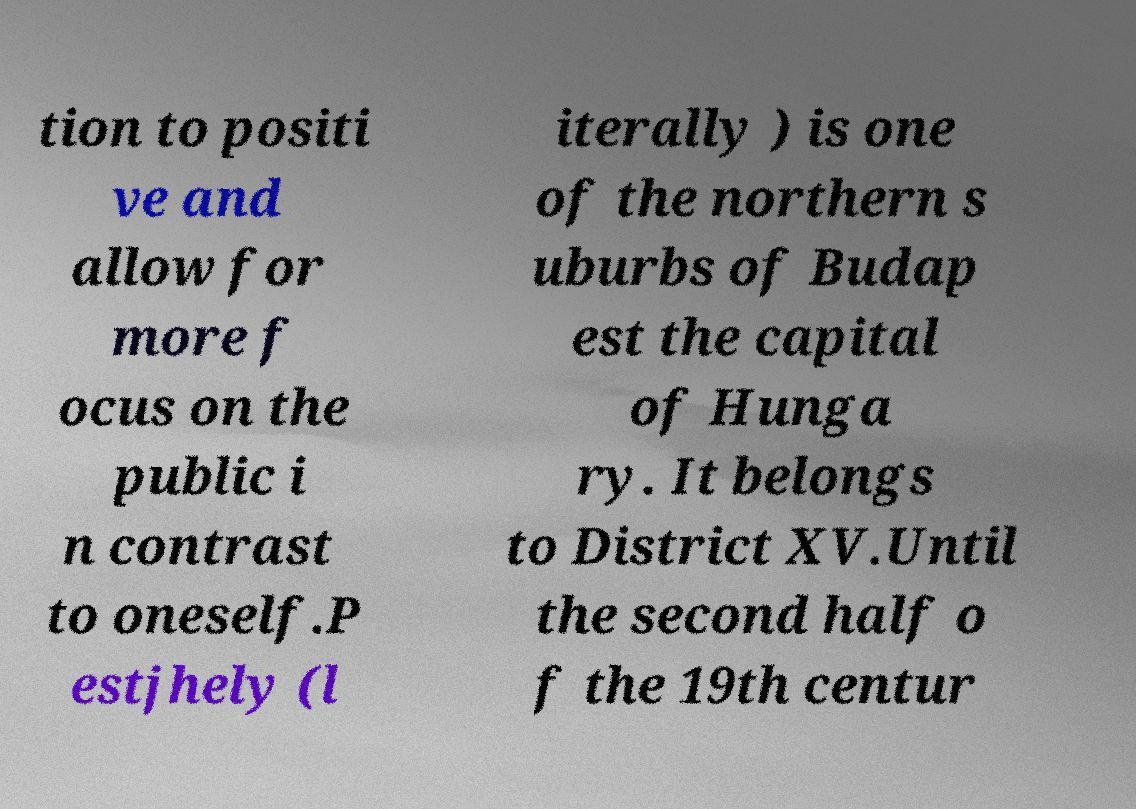Please read and relay the text visible in this image. What does it say? tion to positi ve and allow for more f ocus on the public i n contrast to oneself.P estjhely (l iterally ) is one of the northern s uburbs of Budap est the capital of Hunga ry. It belongs to District XV.Until the second half o f the 19th centur 